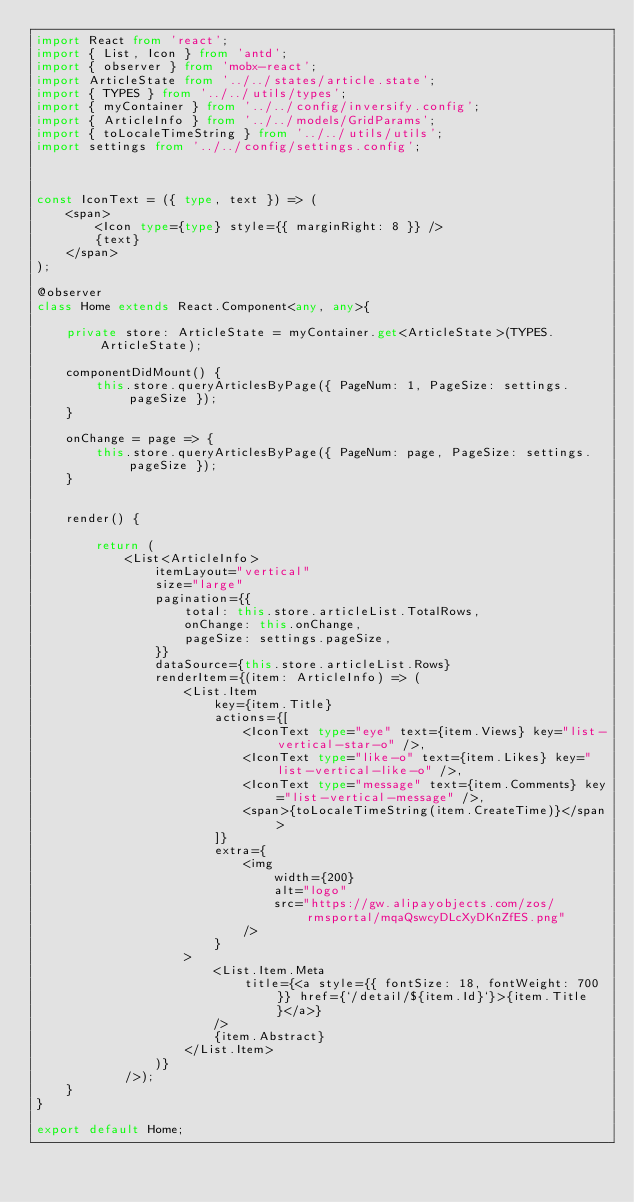<code> <loc_0><loc_0><loc_500><loc_500><_TypeScript_>import React from 'react';
import { List, Icon } from 'antd';
import { observer } from 'mobx-react';
import ArticleState from '../../states/article.state';
import { TYPES } from '../../utils/types';
import { myContainer } from '../../config/inversify.config';
import { ArticleInfo } from '../../models/GridParams';
import { toLocaleTimeString } from '../../utils/utils';
import settings from '../../config/settings.config';



const IconText = ({ type, text }) => (
    <span>
        <Icon type={type} style={{ marginRight: 8 }} />
        {text}
    </span>
);

@observer
class Home extends React.Component<any, any>{

    private store: ArticleState = myContainer.get<ArticleState>(TYPES.ArticleState);

    componentDidMount() {
        this.store.queryArticlesByPage({ PageNum: 1, PageSize: settings.pageSize });
    }

    onChange = page => {
        this.store.queryArticlesByPage({ PageNum: page, PageSize: settings.pageSize });
    }


    render() {

        return (
            <List<ArticleInfo>
                itemLayout="vertical"
                size="large"
                pagination={{
                    total: this.store.articleList.TotalRows,
                    onChange: this.onChange,
                    pageSize: settings.pageSize,
                }}
                dataSource={this.store.articleList.Rows}
                renderItem={(item: ArticleInfo) => (
                    <List.Item
                        key={item.Title}
                        actions={[
                            <IconText type="eye" text={item.Views} key="list-vertical-star-o" />,
                            <IconText type="like-o" text={item.Likes} key="list-vertical-like-o" />,
                            <IconText type="message" text={item.Comments} key="list-vertical-message" />,
                            <span>{toLocaleTimeString(item.CreateTime)}</span>
                        ]}
                        extra={
                            <img
                                width={200}
                                alt="logo"
                                src="https://gw.alipayobjects.com/zos/rmsportal/mqaQswcyDLcXyDKnZfES.png"
                            />
                        }
                    >
                        <List.Item.Meta
                            title={<a style={{ fontSize: 18, fontWeight: 700 }} href={`/detail/${item.Id}`}>{item.Title}</a>}
                        />
                        {item.Abstract}
                    </List.Item>
                )}
            />);
    }
}

export default Home;
</code> 